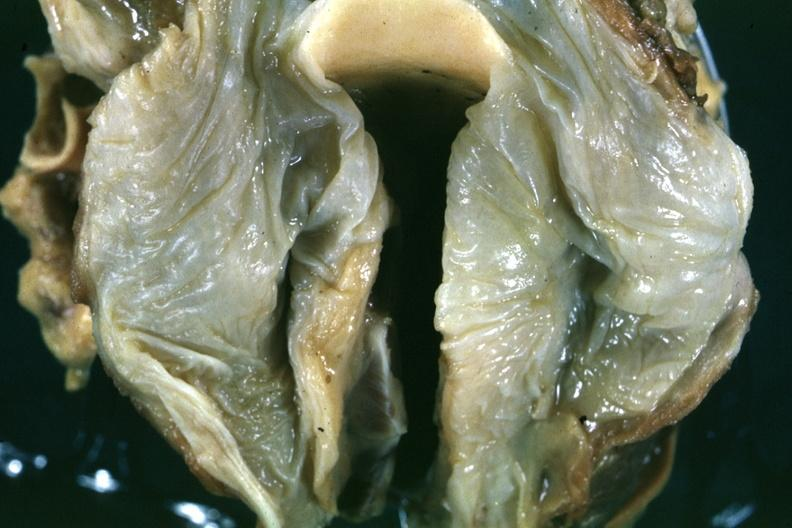what is present?
Answer the question using a single word or phrase. Oral 